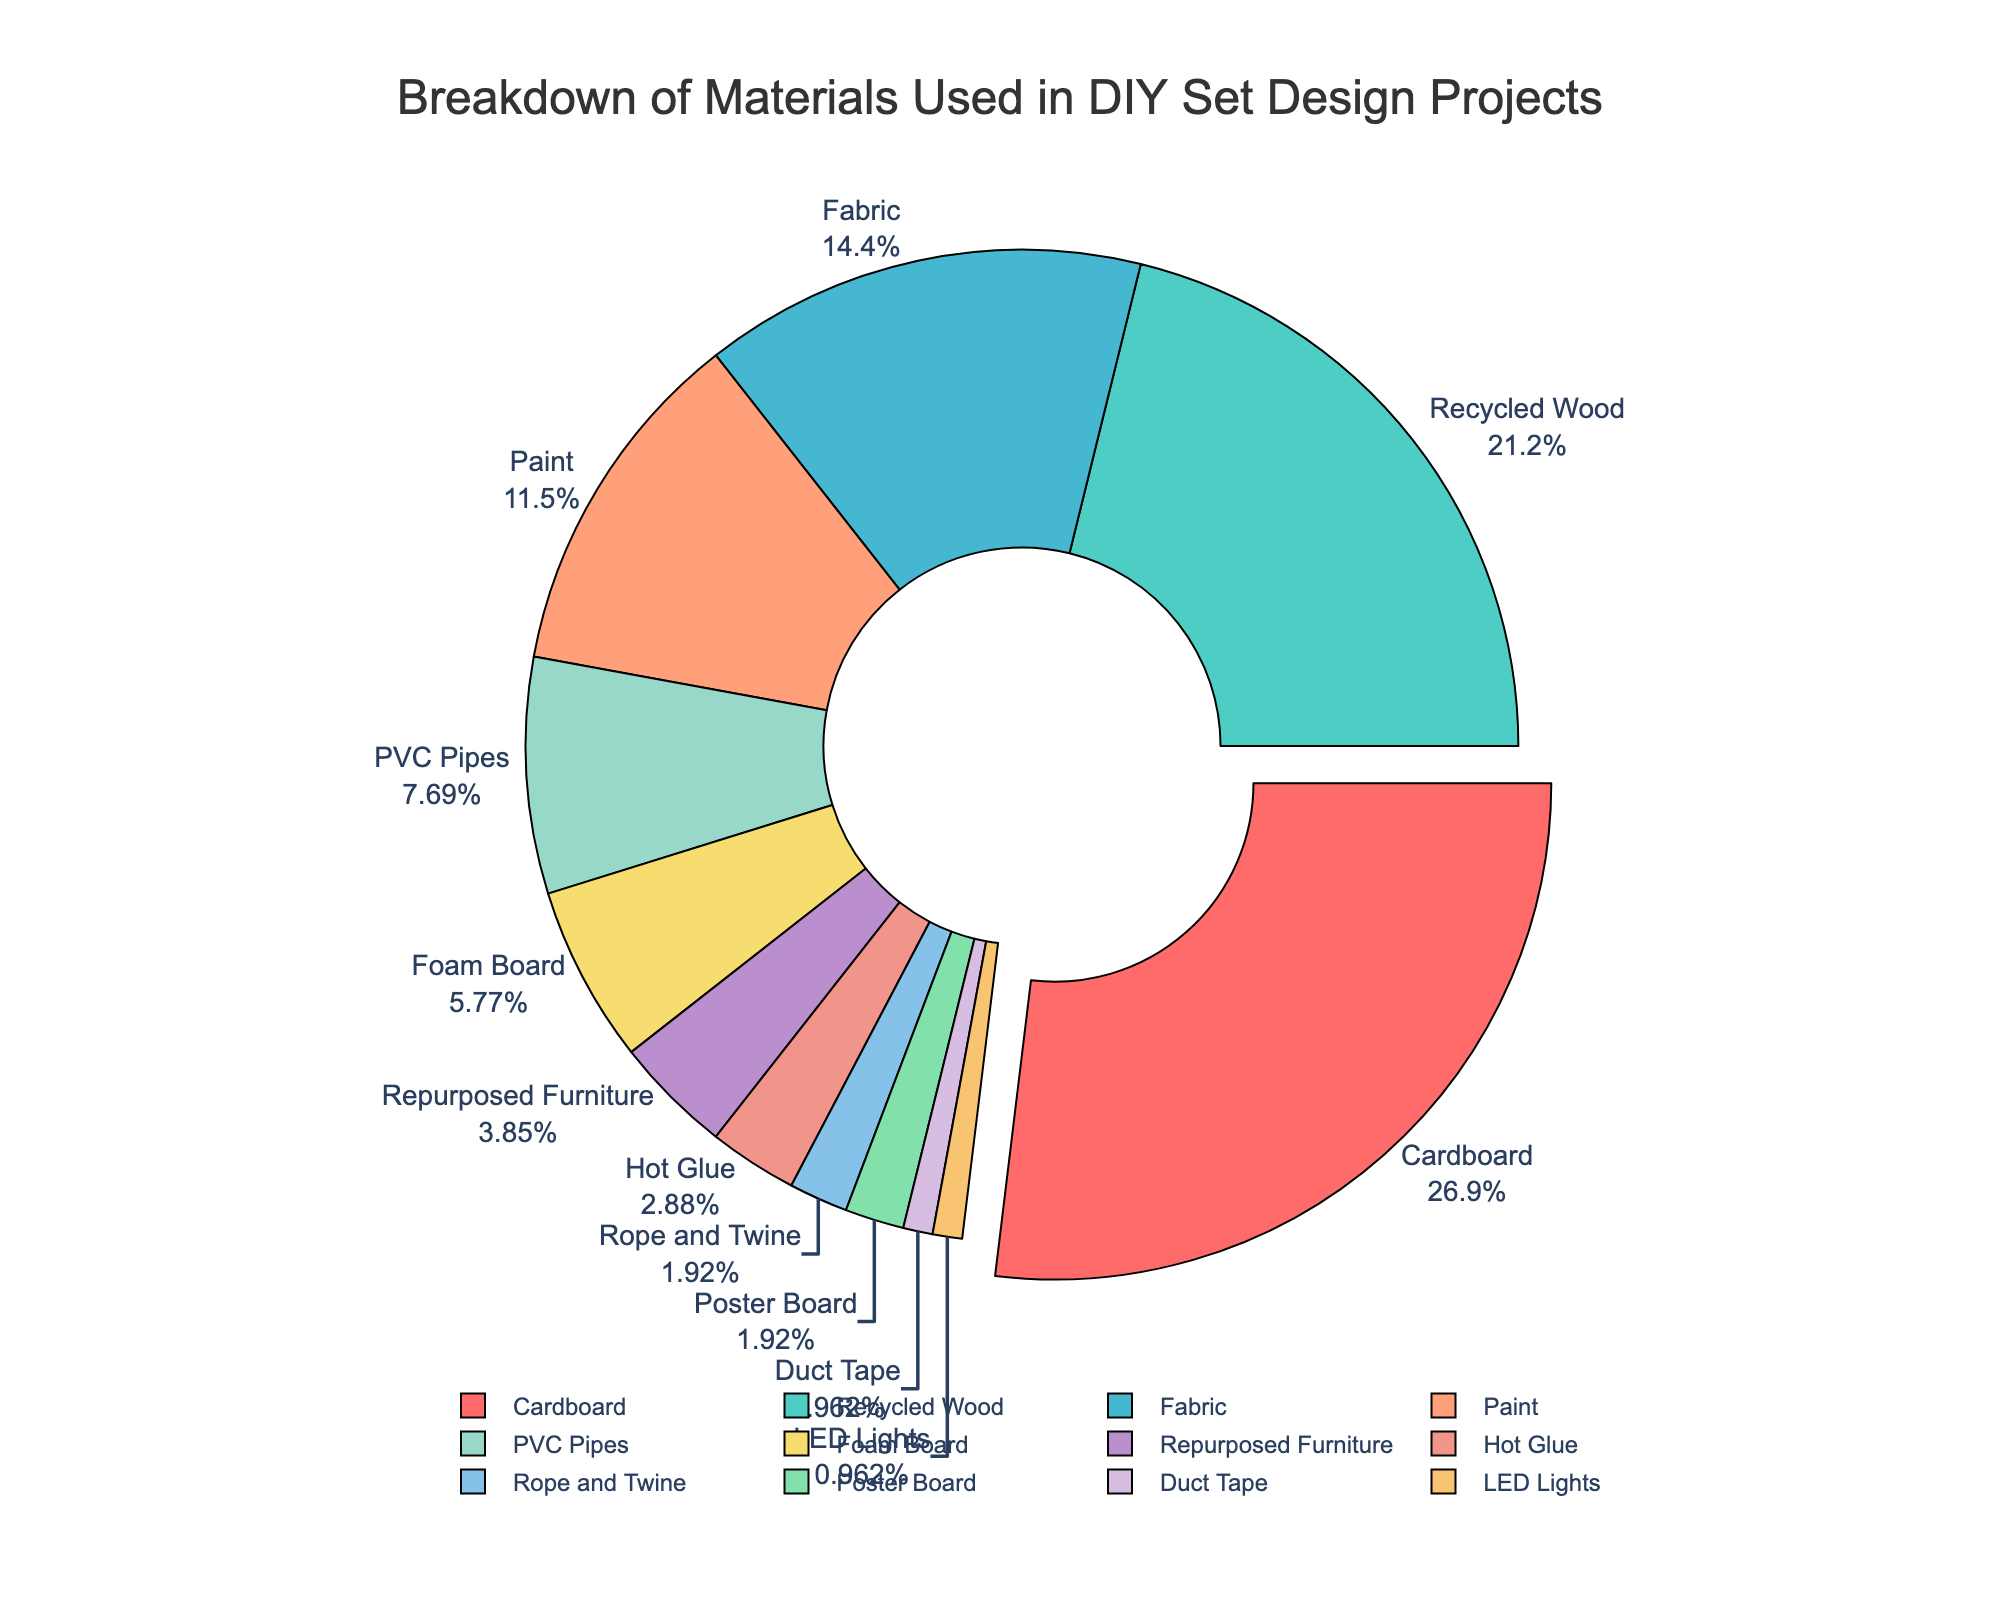What material is used the most in DIY set design projects? The pie chart shows that "Cardboard" has the largest slice, indicating it is used the most.
Answer: Cardboard What is the difference in percentage between Cardboard and Recycled Wood? Cardboard has 28% and Recycled Wood has 22%. Subtracting 22 from 28 gives 6.
Answer: 6% How much more is the combined percentage of Cardboard and Recycled Wood compared to the combined percentage of Foam Board and Hot Glue? The sum of Cardboard (28%) and Recycled Wood (22%) is 50%. The sum of Foam Board (6%) and Hot Glue (3%) is 9%. Subtracting 9 from 50 gives 41.
Answer: 41% Which three materials have the smallest usage percentages? The smallest slices indicated on the pie chart are "Rope and Twine" (2%), "Poster Board" (2%), "Duct Tape" (1%), and "LED Lights" (1%). Among these, three materials would be Duct Tape, LED Lights, and one from Rope and Twine or Poster Board.
Answer: Duct Tape, LED Lights, and either Poster Board or Rope and Twine What percentage of materials are used in categories with less than 10% each? Adding the percentages of PVC Pipes (8%), Foam Board (6%), Repurposed Furniture (4%), Hot Glue (3%), Rope and Twine (2%), Poster Board (2%), Duct Tape (1%), and LED Lights (1%) gives 27.
Answer: 27% Which material is represented by the slice just next to the largest slice? Looking at the pie chart, the slice just next to the largest slice (Cardboard) is "Recycled Wood."
Answer: Recycled Wood Are there any materials that have equal usage percentages? The pie chart indicates that "Rope and Twine" and "Poster Board" both have 2%.
Answer: Yes Which material makes up a quarter of the total materials used? Cardboard is shown to make up 28%, which is slightly more than a quarter (25%).
Answer: Cardboard What is the total percentage of the top three materials used? Adding the percentages of Cardboard (28%), Recycled Wood (22%), and Fabric (15%) gives 65.
Answer: 65% How does the usage of Paint compare to Fabric? The pie chart shows Paint at 12% and Fabric at 15%. 15% is greater than 12%, so Fabric is used more.
Answer: Fabric is used more 